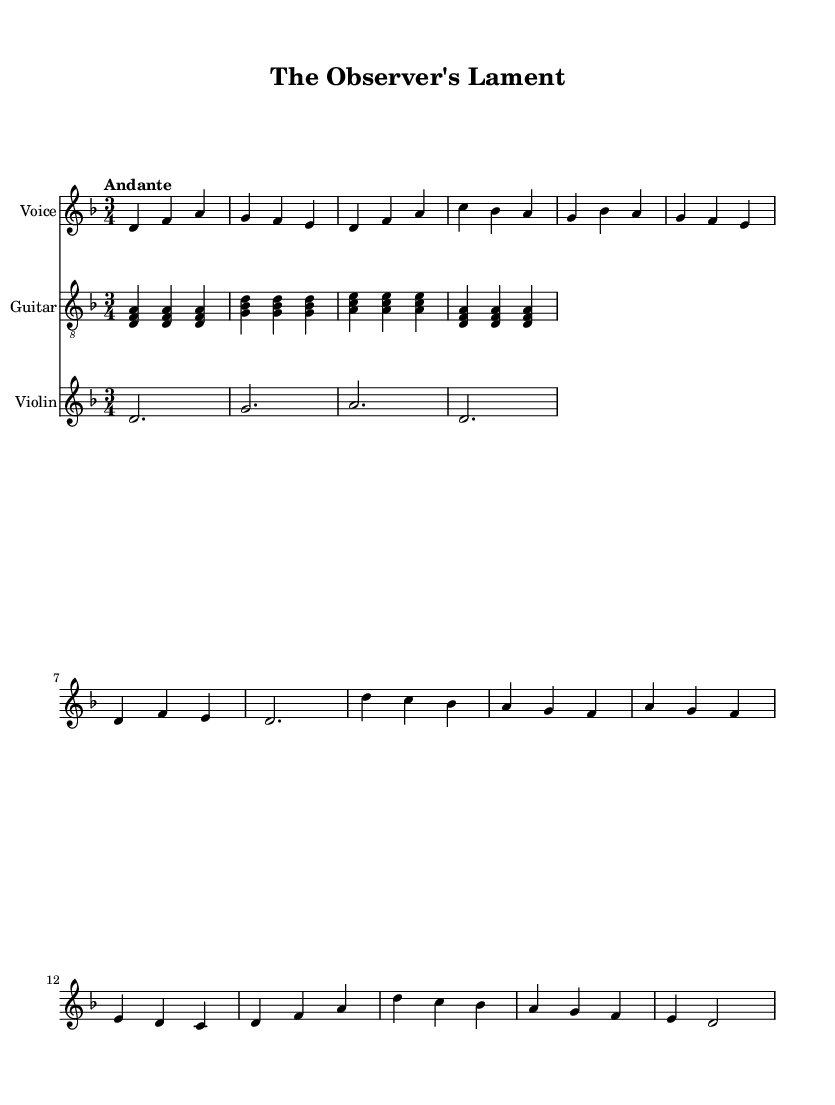What is the key signature of this music? The key is D minor, which has one flat in its key signature. This is indicated at the beginning of the score after the clef symbol.
Answer: D minor What is the time signature of this music? The time signature is 3/4, which is specified at the beginning of the score right after the key signature. It indicates that there are three beats in a measure and that a quarter note receives one beat.
Answer: 3/4 What is the tempo marking for this piece? The tempo marking at the start of the score indicates "Andante," which suggests a moderate pace, typically 76 to 108 beats per minute.
Answer: Andante How many measures are there in the chorus? The chorus consists of eight measures, which can be counted by looking at the separation of the music into distinct groupings marked by the bar lines.
Answer: Eight Which instruments are included in the score? The score includes Voice, Guitar, and Violin. Each instrument is listed as a new staff in the score.
Answer: Voice, Guitar, Violin What do the lyrics in the verse emphasize? The verse lyrics talk about understanding human behavior and the workings of the mind, suggesting a contemplative exploration of psychology.
Answer: Understanding human behavior What social theme is presented in the chorus? The chorus presents a theme of observation and the quest for truth, which reflects on the patterns in human behavior and social dynamics.
Answer: Observation and quest for truth 